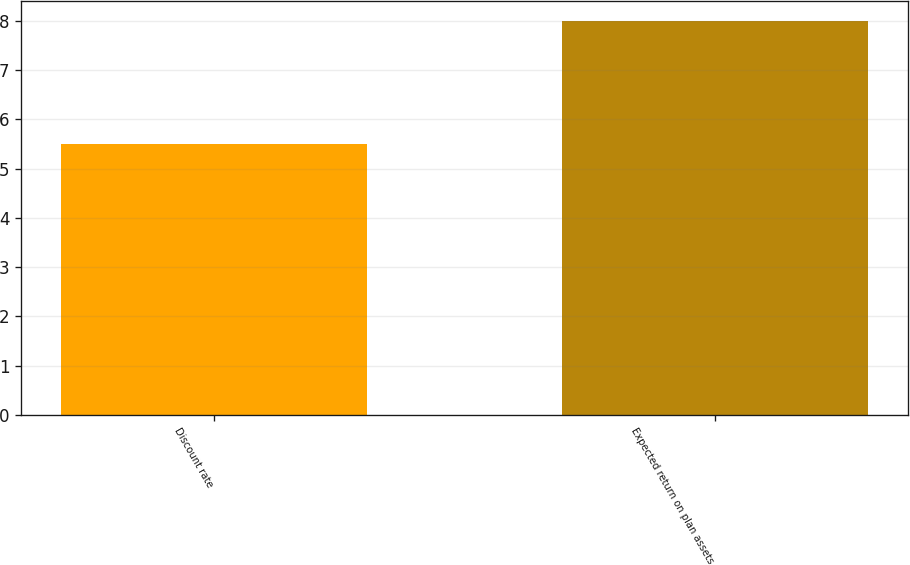Convert chart to OTSL. <chart><loc_0><loc_0><loc_500><loc_500><bar_chart><fcel>Discount rate<fcel>Expected return on plan assets<nl><fcel>5.5<fcel>8<nl></chart> 